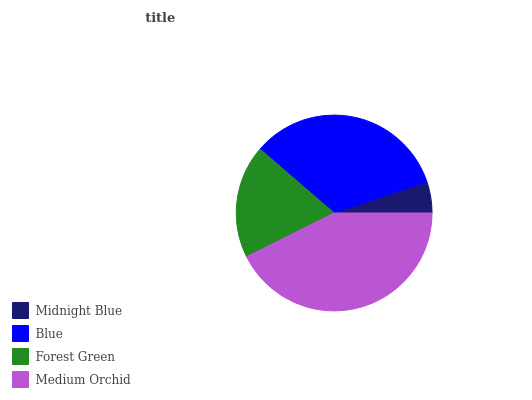Is Midnight Blue the minimum?
Answer yes or no. Yes. Is Medium Orchid the maximum?
Answer yes or no. Yes. Is Blue the minimum?
Answer yes or no. No. Is Blue the maximum?
Answer yes or no. No. Is Blue greater than Midnight Blue?
Answer yes or no. Yes. Is Midnight Blue less than Blue?
Answer yes or no. Yes. Is Midnight Blue greater than Blue?
Answer yes or no. No. Is Blue less than Midnight Blue?
Answer yes or no. No. Is Blue the high median?
Answer yes or no. Yes. Is Forest Green the low median?
Answer yes or no. Yes. Is Medium Orchid the high median?
Answer yes or no. No. Is Medium Orchid the low median?
Answer yes or no. No. 